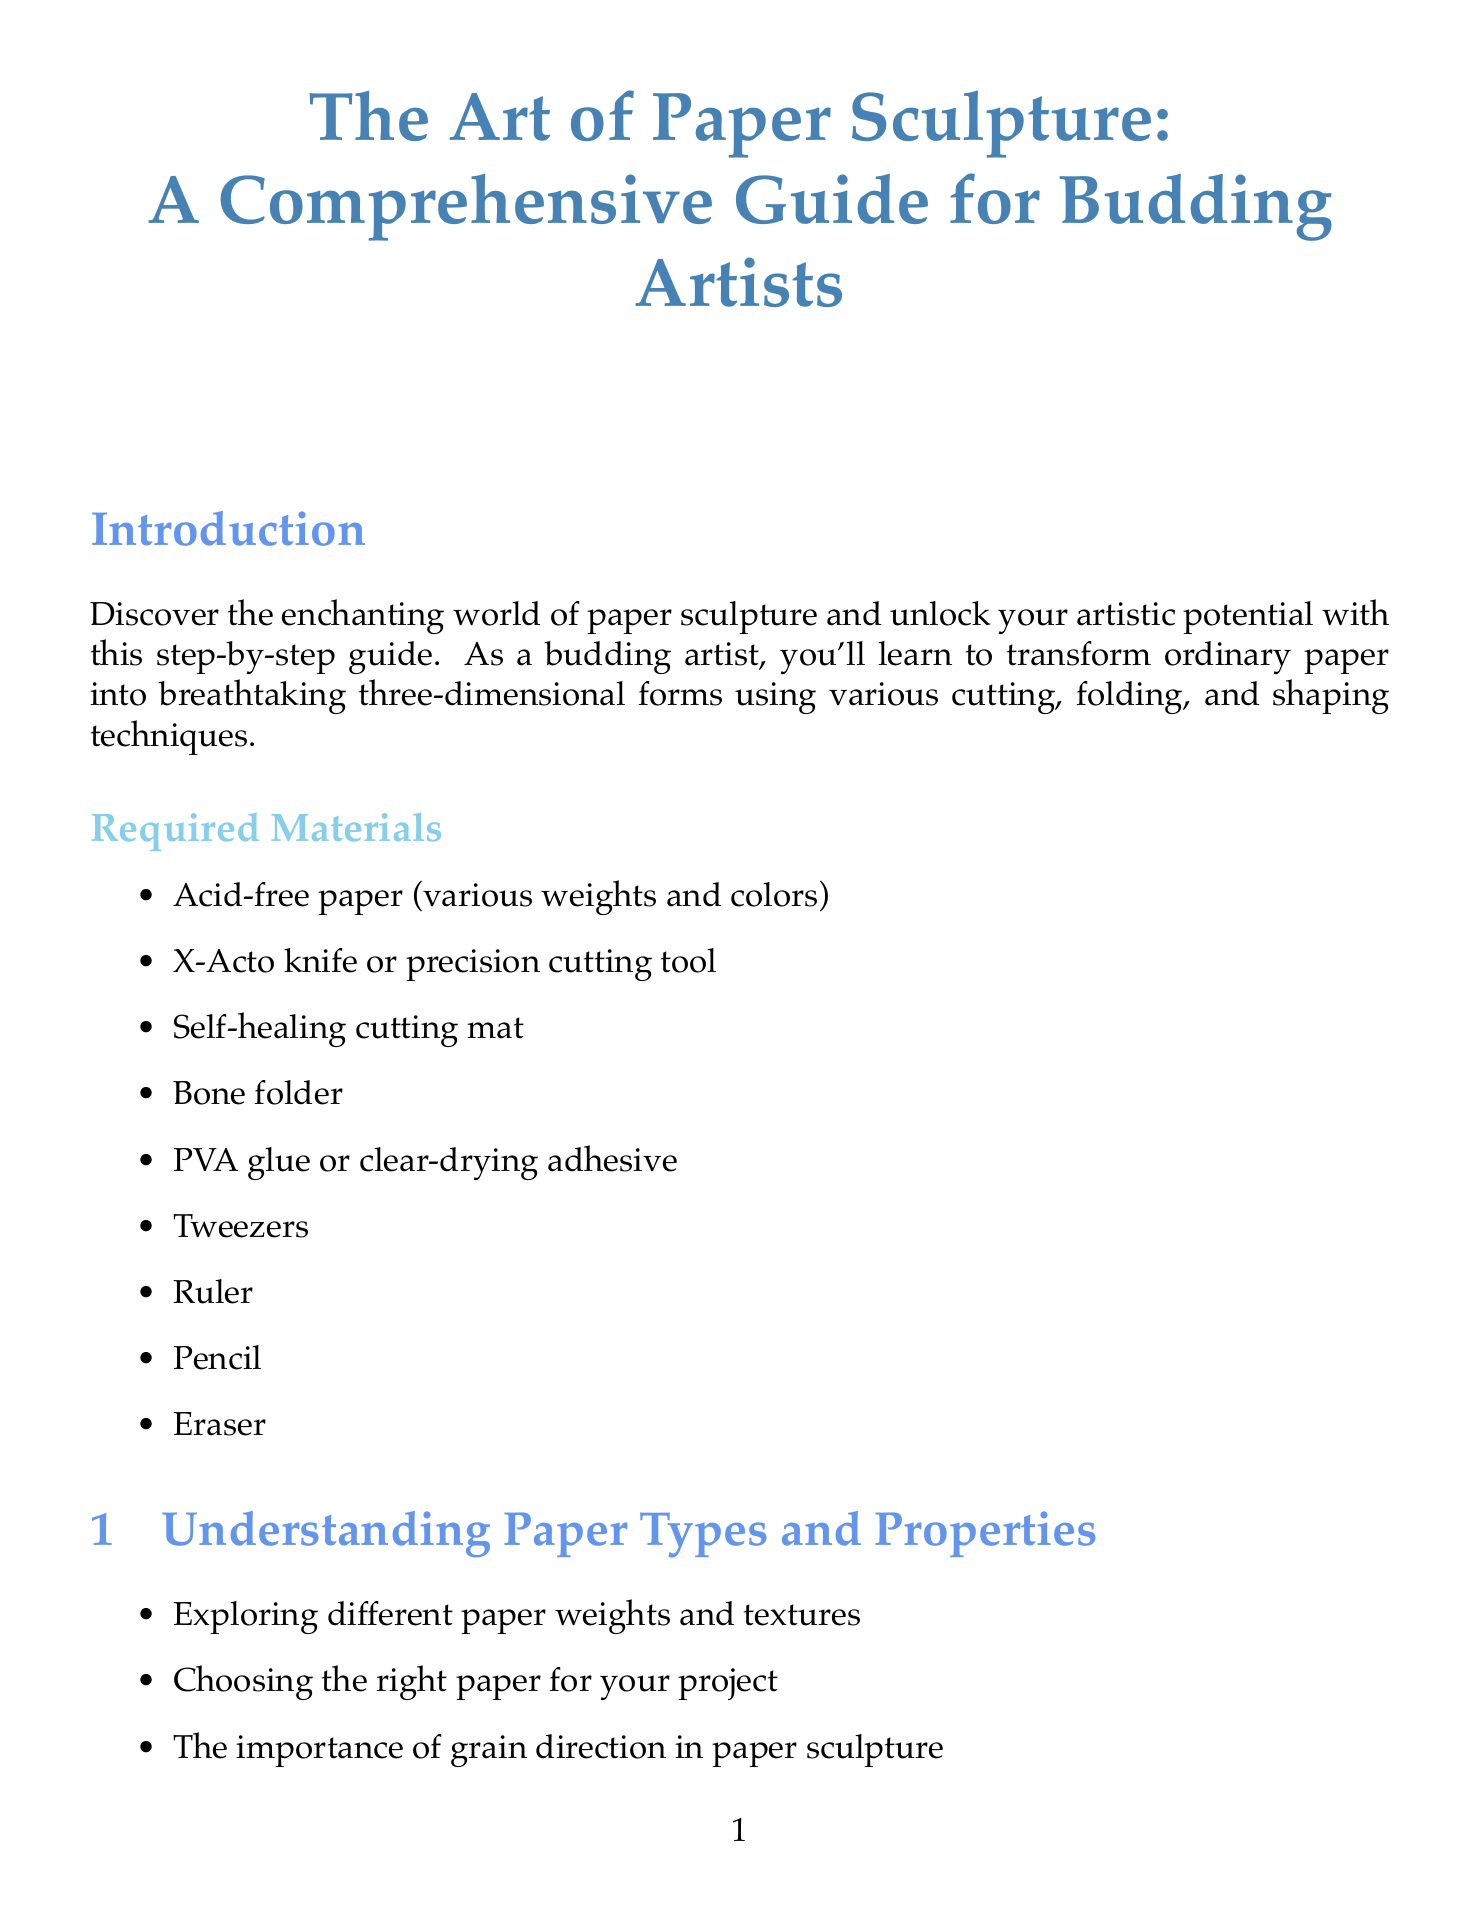What is the title of the guide? The title describes the overall content and purpose of the document, which is about paper sculpture.
Answer: The Art of Paper Sculpture: A Comprehensive Guide for Budding Artists How many project tutorials are included in the document? The number of project tutorials is listed in the Project Tutorials section.
Answer: Three What is one of the essential materials required for creating paper sculptures? The required materials are listed in the Introduction section.
Answer: Acid-free paper Which chapter covers advanced paper sculpture techniques? The titles of the chapters are provided in a structured format throughout the document.
Answer: Advanced Paper Sculpture Techniques What is the difficulty level of the "Blooming Paper Flower Bouquet" project? The difficulty levels for each project tutorial are specified under each project name.
Answer: Beginner What technique is described for creating volume and dimension in paper sculpture? The techniques for shaping paper can be found in the relevant section discussing shaping and forming methods.
Answer: Scoring and bending What is one online community mentioned for paper sculpture enthusiasts? Online communities are listed in the Resources section for further engagement with others interested in paper sculpture.
Answer: Reddit r/papercraft What is the purpose of using a bone folder in paper sculpture? The Introduction outlines various tools and their applications in paper shaping and folding techniques.
Answer: Creating crisp, precise folds 